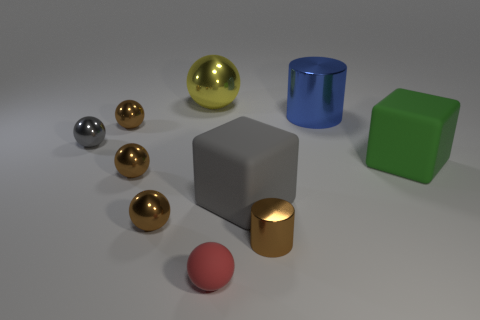What is the small cylinder made of?
Ensure brevity in your answer.  Metal. What shape is the green rubber thing that is the same size as the yellow object?
Keep it short and to the point. Cube. Is the material of the large thing that is on the right side of the large metal cylinder the same as the sphere behind the blue metallic object?
Your answer should be very brief. No. How many small red cylinders are there?
Offer a terse response. 0. How many brown things have the same shape as the blue metal object?
Provide a succinct answer. 1. Is the gray metal object the same shape as the big gray thing?
Ensure brevity in your answer.  No. The matte ball has what size?
Offer a very short reply. Small. How many other yellow balls have the same size as the rubber ball?
Ensure brevity in your answer.  0. Does the matte thing that is left of the large gray cube have the same size as the cube that is to the right of the big cylinder?
Give a very brief answer. No. What shape is the small red thing in front of the tiny cylinder?
Your answer should be compact. Sphere. 